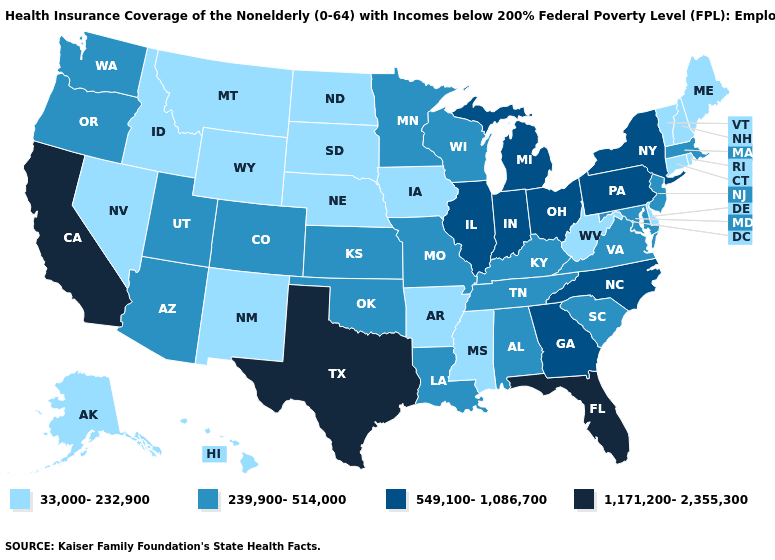What is the value of Wyoming?
Short answer required. 33,000-232,900. What is the lowest value in the USA?
Quick response, please. 33,000-232,900. Does the map have missing data?
Keep it brief. No. Which states hav the highest value in the Northeast?
Be succinct. New York, Pennsylvania. Name the states that have a value in the range 33,000-232,900?
Answer briefly. Alaska, Arkansas, Connecticut, Delaware, Hawaii, Idaho, Iowa, Maine, Mississippi, Montana, Nebraska, Nevada, New Hampshire, New Mexico, North Dakota, Rhode Island, South Dakota, Vermont, West Virginia, Wyoming. Does Pennsylvania have a higher value than Georgia?
Be succinct. No. Name the states that have a value in the range 239,900-514,000?
Quick response, please. Alabama, Arizona, Colorado, Kansas, Kentucky, Louisiana, Maryland, Massachusetts, Minnesota, Missouri, New Jersey, Oklahoma, Oregon, South Carolina, Tennessee, Utah, Virginia, Washington, Wisconsin. Among the states that border Indiana , does Illinois have the lowest value?
Give a very brief answer. No. Does California have the lowest value in the USA?
Give a very brief answer. No. What is the value of Colorado?
Answer briefly. 239,900-514,000. Name the states that have a value in the range 549,100-1,086,700?
Short answer required. Georgia, Illinois, Indiana, Michigan, New York, North Carolina, Ohio, Pennsylvania. Does North Carolina have the lowest value in the South?
Give a very brief answer. No. Which states have the highest value in the USA?
Give a very brief answer. California, Florida, Texas. What is the value of Indiana?
Keep it brief. 549,100-1,086,700. Which states have the highest value in the USA?
Give a very brief answer. California, Florida, Texas. 